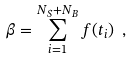<formula> <loc_0><loc_0><loc_500><loc_500>\beta = \sum _ { i = 1 } ^ { N _ { S } + N _ { B } } f ( t _ { i } ) \ ,</formula> 